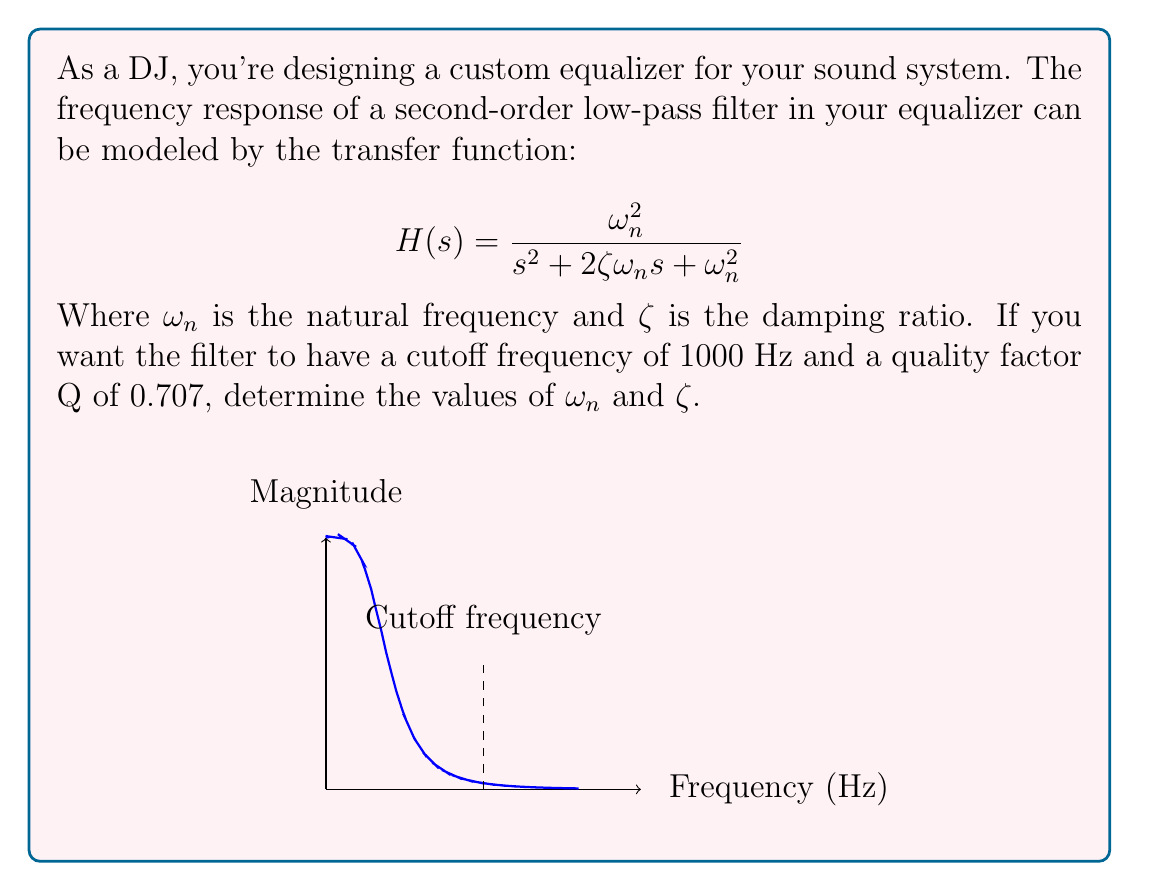Teach me how to tackle this problem. Let's approach this step-by-step:

1) First, recall that for a second-order low-pass filter:
   $\omega_n = 2\pi f_c$, where $f_c$ is the cutoff frequency.

2) Given $f_c = 1000$ Hz, we can calculate $\omega_n$:
   $\omega_n = 2\pi(1000) = 2000\pi$ rad/s

3) Next, we know that the quality factor Q is related to the damping ratio $\zeta$ by:
   $Q = \frac{1}{2\zeta}$

4) We're given that Q = 0.707. Let's substitute this:
   $0.707 = \frac{1}{2\zeta}$

5) Solving for $\zeta$:
   $\zeta = \frac{1}{2(0.707)} \approx 0.707$

6) We can verify that this makes sense, as a damping ratio of $\frac{1}{\sqrt{2}} \approx 0.707$ is often used for a "maximally flat" response, which aligns with the given Q factor.
Answer: $\omega_n = 2000\pi$ rad/s, $\zeta \approx 0.707$ 